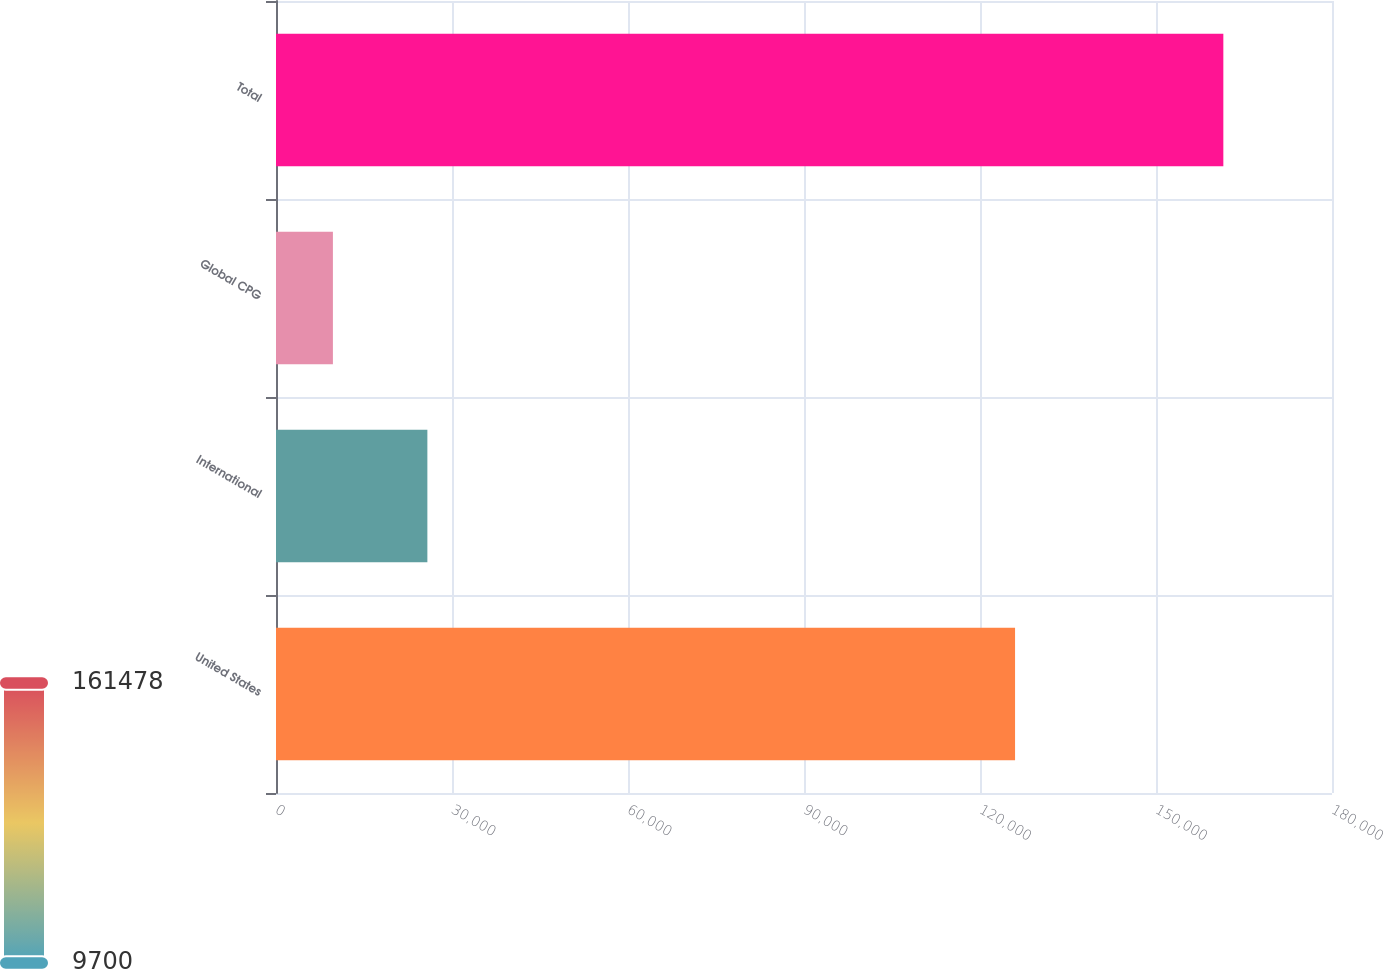Convert chart. <chart><loc_0><loc_0><loc_500><loc_500><bar_chart><fcel>United States<fcel>International<fcel>Global CPG<fcel>Total<nl><fcel>125976<fcel>25802<fcel>9700<fcel>161478<nl></chart> 